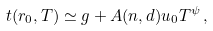<formula> <loc_0><loc_0><loc_500><loc_500>t ( r _ { 0 } , T ) \simeq g + A ( n , d ) u _ { 0 } T ^ { \psi } \, ,</formula> 